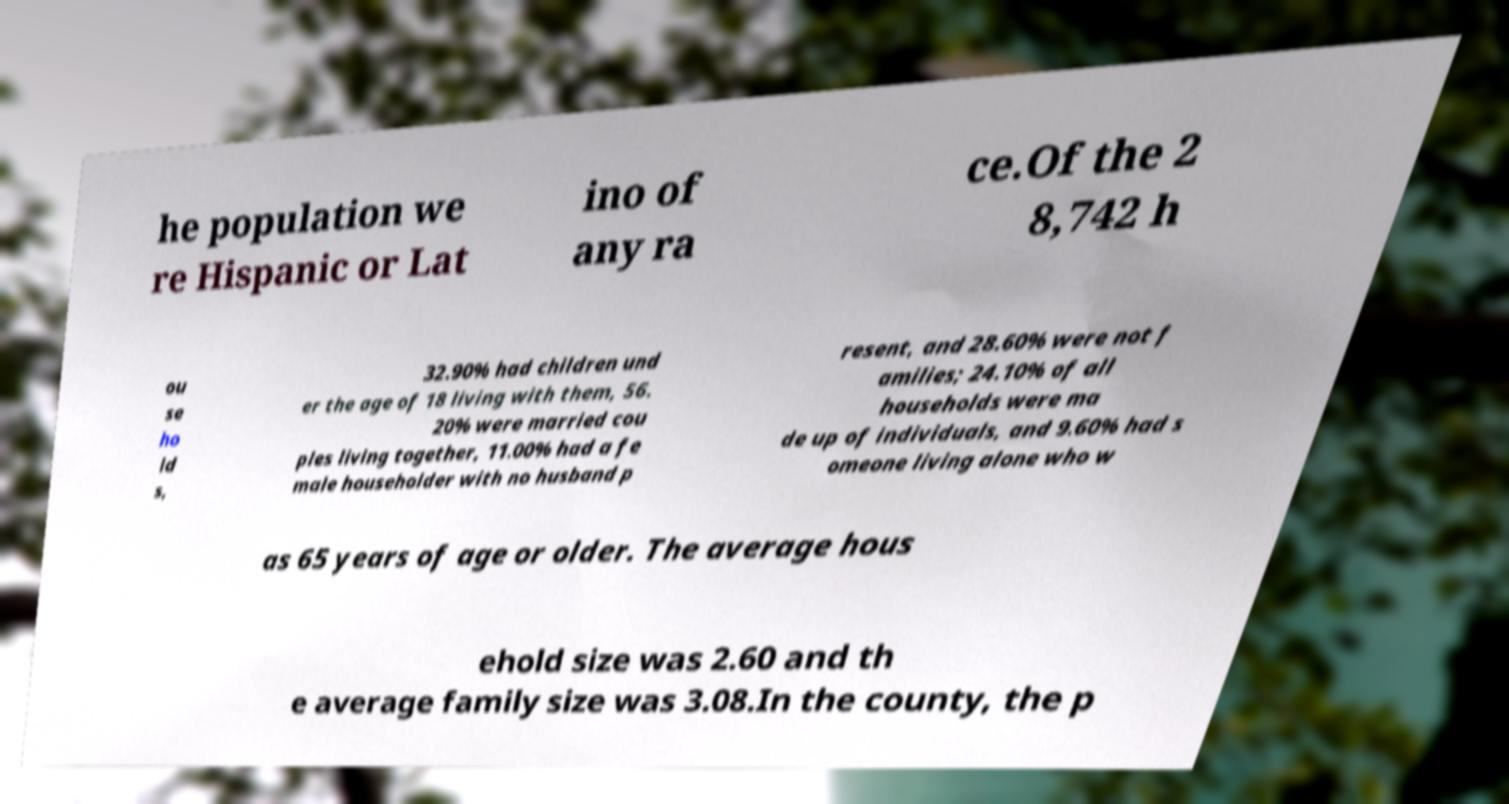Please read and relay the text visible in this image. What does it say? he population we re Hispanic or Lat ino of any ra ce.Of the 2 8,742 h ou se ho ld s, 32.90% had children und er the age of 18 living with them, 56. 20% were married cou ples living together, 11.00% had a fe male householder with no husband p resent, and 28.60% were not f amilies; 24.10% of all households were ma de up of individuals, and 9.60% had s omeone living alone who w as 65 years of age or older. The average hous ehold size was 2.60 and th e average family size was 3.08.In the county, the p 